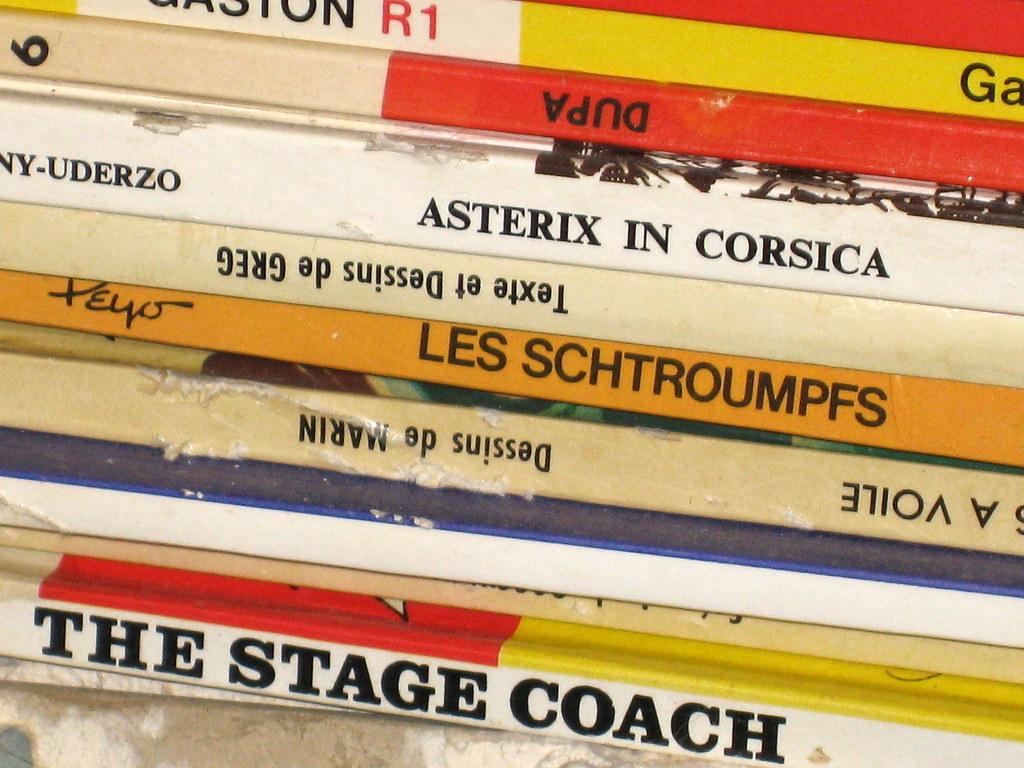Which one is about the stage coach?
Provide a succinct answer. The bottom one. What is the title of the orange book?
Ensure brevity in your answer.  Les schtroumpfs. 